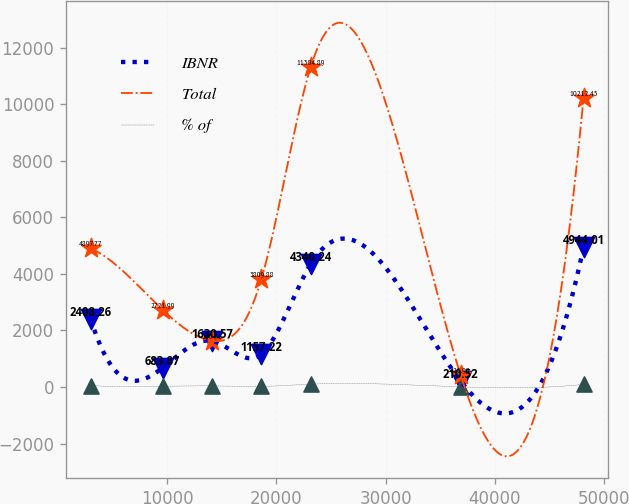Convert chart to OTSL. <chart><loc_0><loc_0><loc_500><loc_500><line_chart><ecel><fcel>IBNR<fcel>Total<fcel>% of<nl><fcel>2964.62<fcel>2408.26<fcel>4897.77<fcel>47.44<nl><fcel>9578.18<fcel>683.87<fcel>2721.99<fcel>28.7<nl><fcel>14096.9<fcel>1630.57<fcel>1634.1<fcel>38.07<nl><fcel>18615.5<fcel>1157.22<fcel>3809.88<fcel>19.33<nl><fcel>23134.2<fcel>4340.24<fcel>11304.9<fcel>100.33<nl><fcel>36881.9<fcel>210.52<fcel>425.98<fcel>4.63<nl><fcel>48151.4<fcel>4944.01<fcel>10212.5<fcel>90.96<nl></chart> 